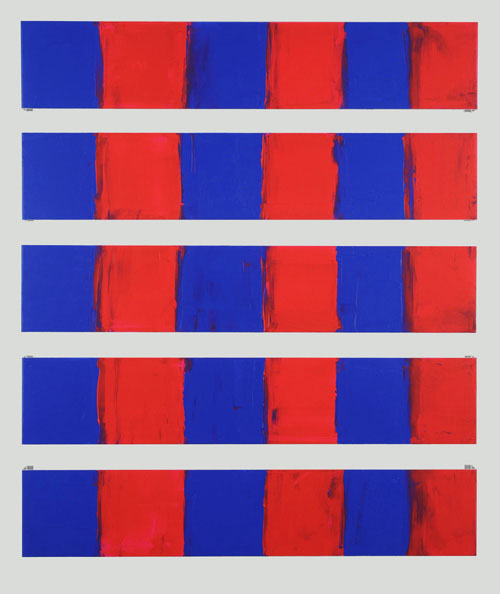Explain the visual content of the image in great detail. The image is an abstract art piece consisting of nine vertical rectangular panels arranged in a grid format. Each panel is bisected into two sections, one red and the other blue. The borders between the colors are irregular, implying that the red paint has been applied over the blue. This layering effect creates a dynamic sense of depth and movement within the piece. The arrangement of the panels adds a repetitive and symmetrical structure, commonly found in abstract and minimalist art. The artwork's emphasis on bold, solid colors bears a resemblance to color field painting, highlighting the emotive power of large color areas and the interplay between the two dominant hues. 